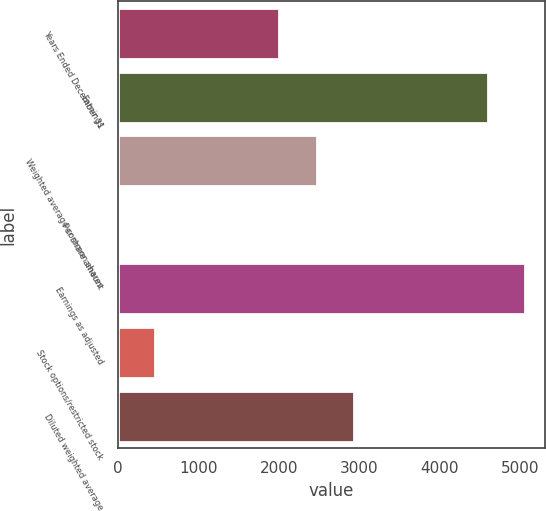Convert chart to OTSL. <chart><loc_0><loc_0><loc_500><loc_500><bar_chart><fcel>Years Ended December 31<fcel>Earnings<fcel>Weighted average common shares<fcel>Per share amount<fcel>Earnings as adjusted<fcel>Stock options/restricted stock<fcel>Diluted weighted average<nl><fcel>2005<fcel>4599<fcel>2471.3<fcel>1.86<fcel>5058.71<fcel>461.57<fcel>2931.01<nl></chart> 